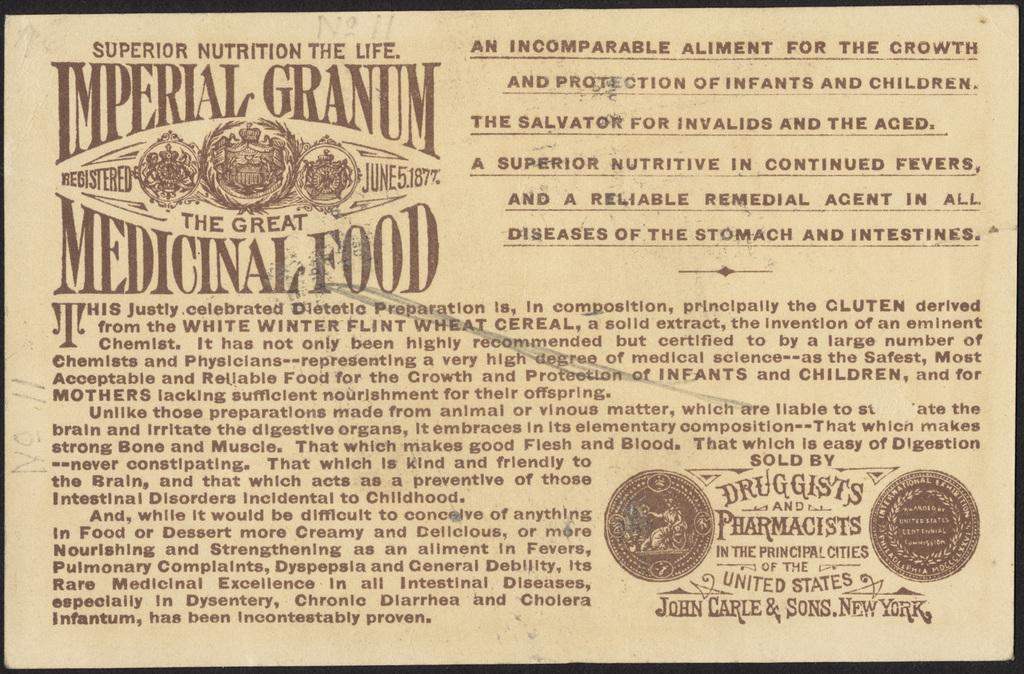<image>
Share a concise interpretation of the image provided. Imperial granium the great medicinal food certification sign 